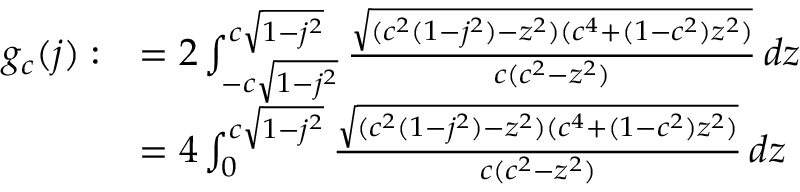<formula> <loc_0><loc_0><loc_500><loc_500>\begin{array} { r l } { g _ { c } ( j ) \colon } & { = 2 \int _ { - c \sqrt { 1 - j ^ { 2 } } } ^ { c \sqrt { 1 - j ^ { 2 } } } \frac { \sqrt { ( c ^ { 2 } ( 1 - j ^ { 2 } ) - z ^ { 2 } ) ( c ^ { 4 } + ( 1 - c ^ { 2 } ) z ^ { 2 } ) } } { c ( c ^ { 2 } - z ^ { 2 } ) } \, d z } \\ & { = 4 \int _ { 0 } ^ { c \sqrt { 1 - j ^ { 2 } } } \frac { \sqrt { ( c ^ { 2 } ( 1 - j ^ { 2 } ) - z ^ { 2 } ) ( c ^ { 4 } + ( 1 - c ^ { 2 } ) z ^ { 2 } ) } } { c ( c ^ { 2 } - z ^ { 2 } ) } \, d z } \end{array}</formula> 